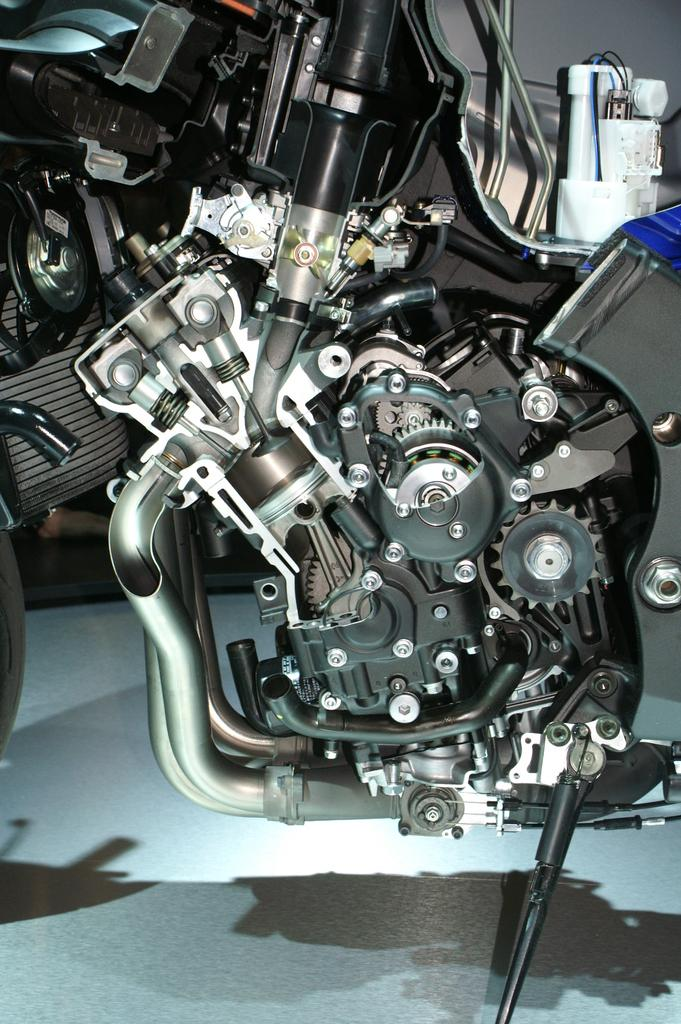What is the main subject of the image? The main subject of the image is the motor of a bike. Is there any additional support or structure visible in the image? Yes, there is a stand at the bottom of the image. Where is the map placed during the dinner in the image? There is no map or dinner present in the image; it only features the motor of a bike and a stand. 